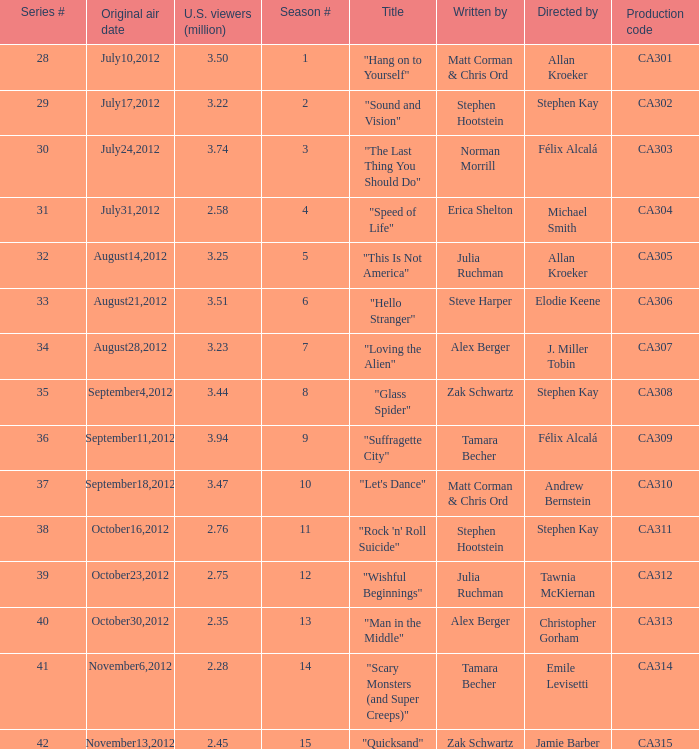What is the series episode number of the episode titled "sound and vision"? 29.0. 